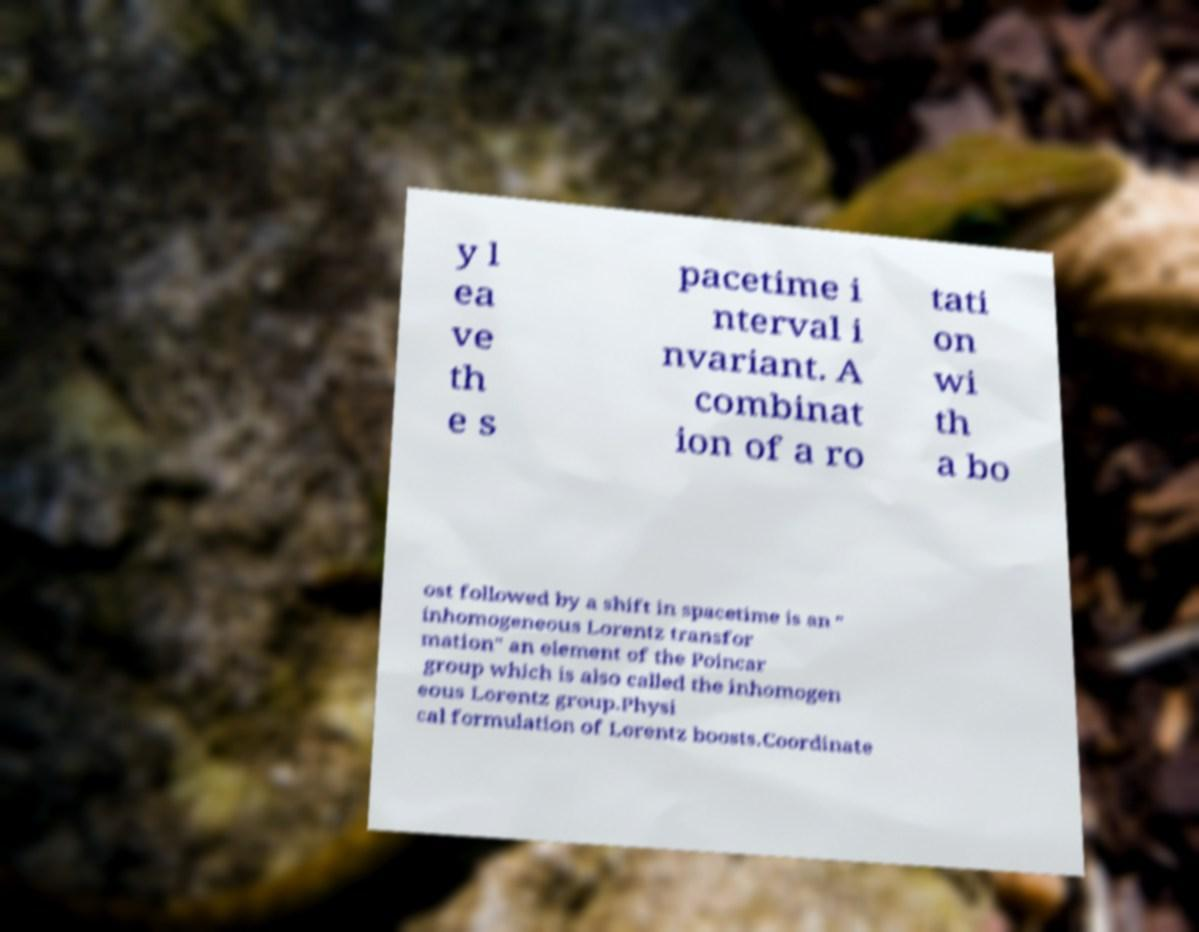Please read and relay the text visible in this image. What does it say? y l ea ve th e s pacetime i nterval i nvariant. A combinat ion of a ro tati on wi th a bo ost followed by a shift in spacetime is an " inhomogeneous Lorentz transfor mation" an element of the Poincar group which is also called the inhomogen eous Lorentz group.Physi cal formulation of Lorentz boosts.Coordinate 